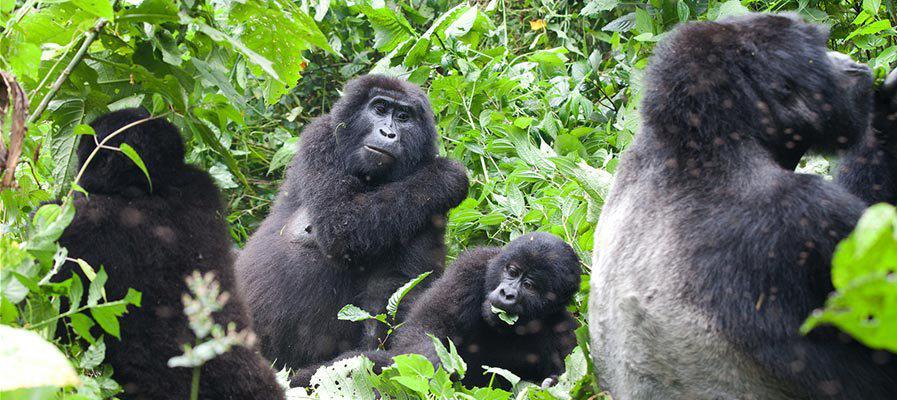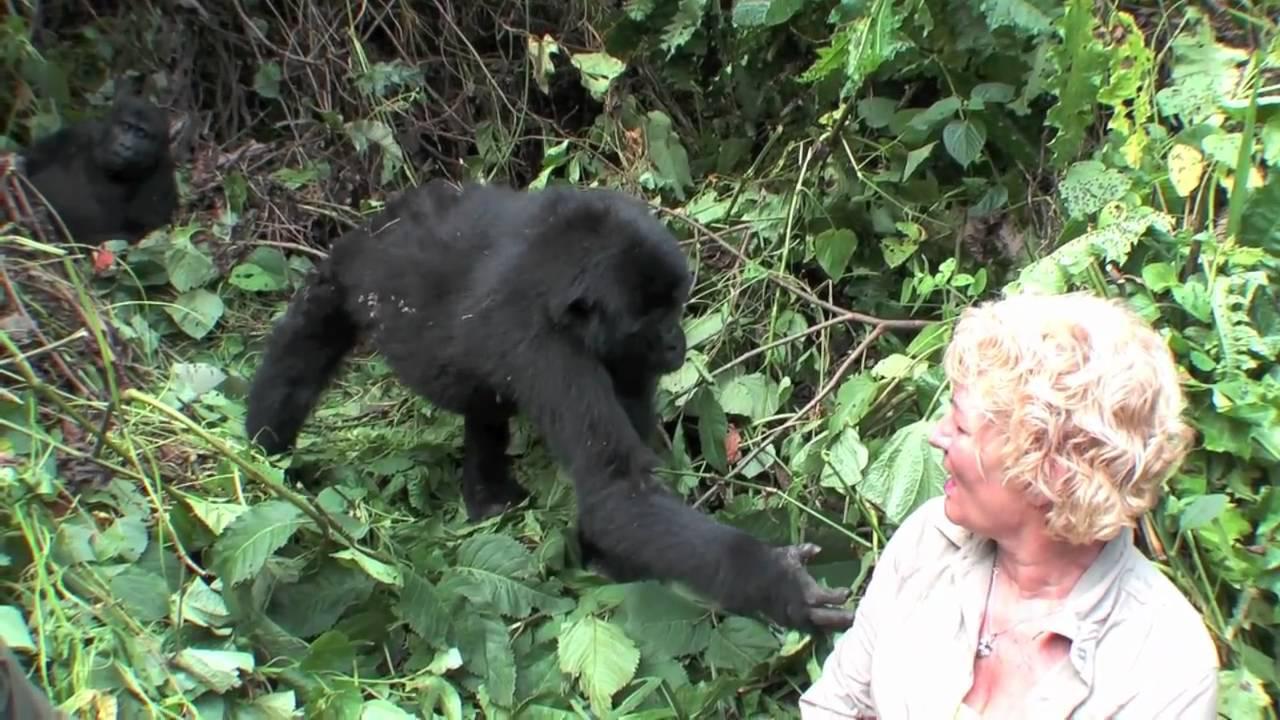The first image is the image on the left, the second image is the image on the right. Given the left and right images, does the statement "There are humans taking pictures of apes in one of the images." hold true? Answer yes or no. No. The first image is the image on the left, the second image is the image on the right. Given the left and right images, does the statement "In the right image, multiple people are near an adult gorilla, and at least one person is holding up a camera." hold true? Answer yes or no. No. 